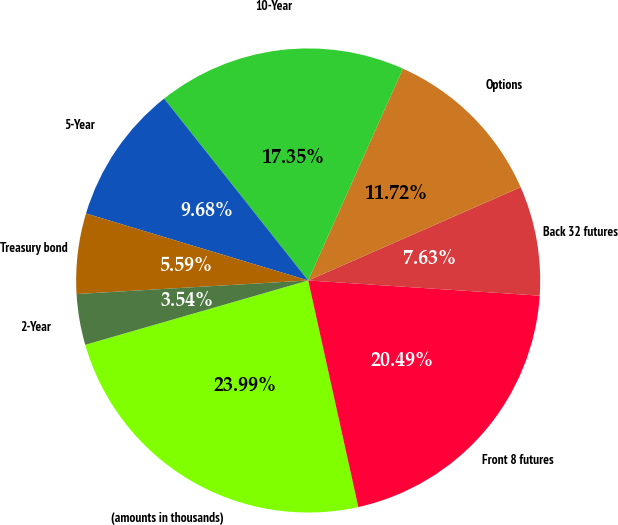Convert chart. <chart><loc_0><loc_0><loc_500><loc_500><pie_chart><fcel>(amounts in thousands)<fcel>Front 8 futures<fcel>Back 32 futures<fcel>Options<fcel>10-Year<fcel>5-Year<fcel>Treasury bond<fcel>2-Year<nl><fcel>23.99%<fcel>20.49%<fcel>7.63%<fcel>11.72%<fcel>17.35%<fcel>9.68%<fcel>5.59%<fcel>3.54%<nl></chart> 